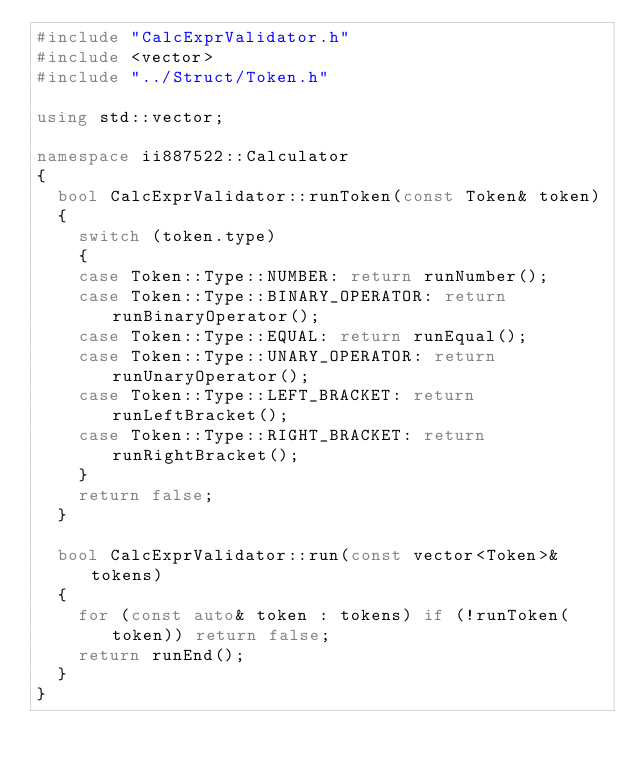Convert code to text. <code><loc_0><loc_0><loc_500><loc_500><_C++_>#include "CalcExprValidator.h"
#include <vector>
#include "../Struct/Token.h"

using std::vector;

namespace ii887522::Calculator
{
	bool CalcExprValidator::runToken(const Token& token)
	{
		switch (token.type)
		{
		case Token::Type::NUMBER: return runNumber();
		case Token::Type::BINARY_OPERATOR: return runBinaryOperator();
		case Token::Type::EQUAL: return runEqual();
		case Token::Type::UNARY_OPERATOR: return runUnaryOperator();
		case Token::Type::LEFT_BRACKET: return runLeftBracket();
		case Token::Type::RIGHT_BRACKET: return runRightBracket();
		}
		return false;
	}

	bool CalcExprValidator::run(const vector<Token>& tokens)
	{
		for (const auto& token : tokens) if (!runToken(token)) return false;
		return runEnd();
	}
}</code> 